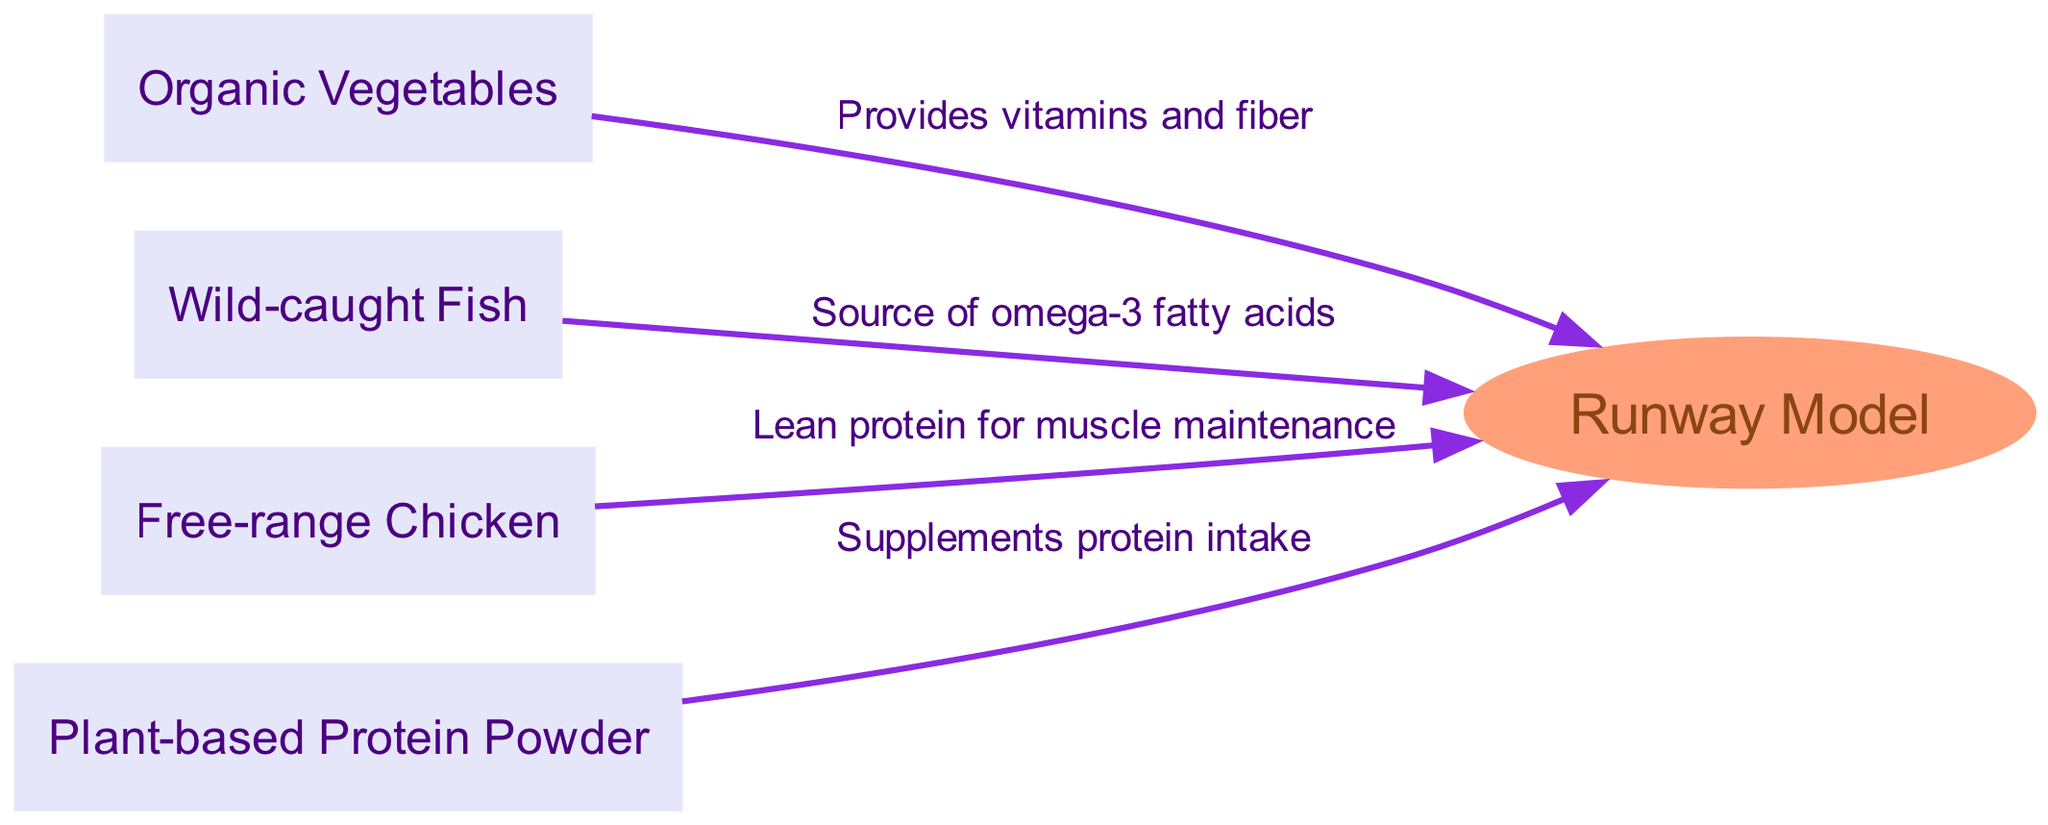What are the main components of a runway model's diet? The diagram lists four main components of a runway model's diet: Organic Vegetables, Wild-caught Fish, Free-range Chicken, and Plant-based Protein Powder.
Answer: Organic Vegetables, Wild-caught Fish, Free-range Chicken, Plant-based Protein Powder What nutritional benefit does Wild-caught Fish provide? According to the diagram, Wild-caught Fish provides omega-3 fatty acids. This is indicated as an edge labeled with this information connecting Wild-caught Fish to the Runway Model.
Answer: Source of omega-3 fatty acids How many nodes are present in the food chain diagram? The diagram shows five nodes: Organic Vegetables, Wild-caught Fish, Free-range Chicken, Plant-based Protein Powder, and Runway Model. Counting these gives us the total number of nodes.
Answer: 5 What relationship exists between Free-range Chicken and the Runway Model? The diagram shows an edge from Free-range Chicken to the Runway Model labeled "Lean protein for muscle maintenance," indicating this nutritional relationship.
Answer: Lean protein for muscle maintenance Which food provides vitamins and fiber to the Runway Model? The edge from Organic Vegetables to the Runway Model is labeled with "Provides vitamins and fiber," indicating this specific benefit.
Answer: Organic Vegetables How many edges are present in the food chain? The diagram has four edges connecting the food sources to the Runway Model, which can be counted visually or inferred from the information provided.
Answer: 4 Which food component supplements protein intake? The diagram identifies Plant-based Protein Powder as providing this benefit, indicated by the edge connecting it to the Runway Model with the label "Supplements protein intake."
Answer: Plant-based Protein Powder What food source is highlighted as a source of lean protein? The diagram explicitly states that Free-range Chicken is labeled as providing lean protein for muscle maintenance, connecting it directly to the Runway Model.
Answer: Free-range Chicken What is the role of Organic Vegetables in the diet of the Runway Model? The edge connecting Organic Vegetables to the Runway Model indicates it provides essential vitamins and fiber, demonstrating its role in the model's diet.
Answer: Provides vitamins and fiber 